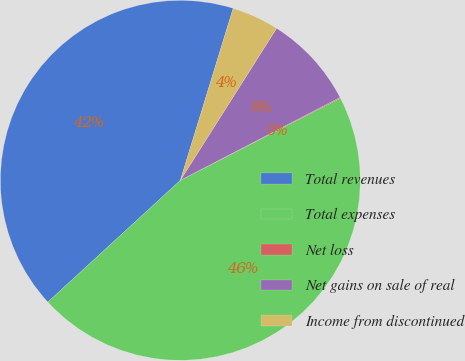Convert chart to OTSL. <chart><loc_0><loc_0><loc_500><loc_500><pie_chart><fcel>Total revenues<fcel>Total expenses<fcel>Net loss<fcel>Net gains on sale of real<fcel>Income from discontinued<nl><fcel>41.57%<fcel>45.72%<fcel>0.08%<fcel>8.39%<fcel>4.24%<nl></chart> 